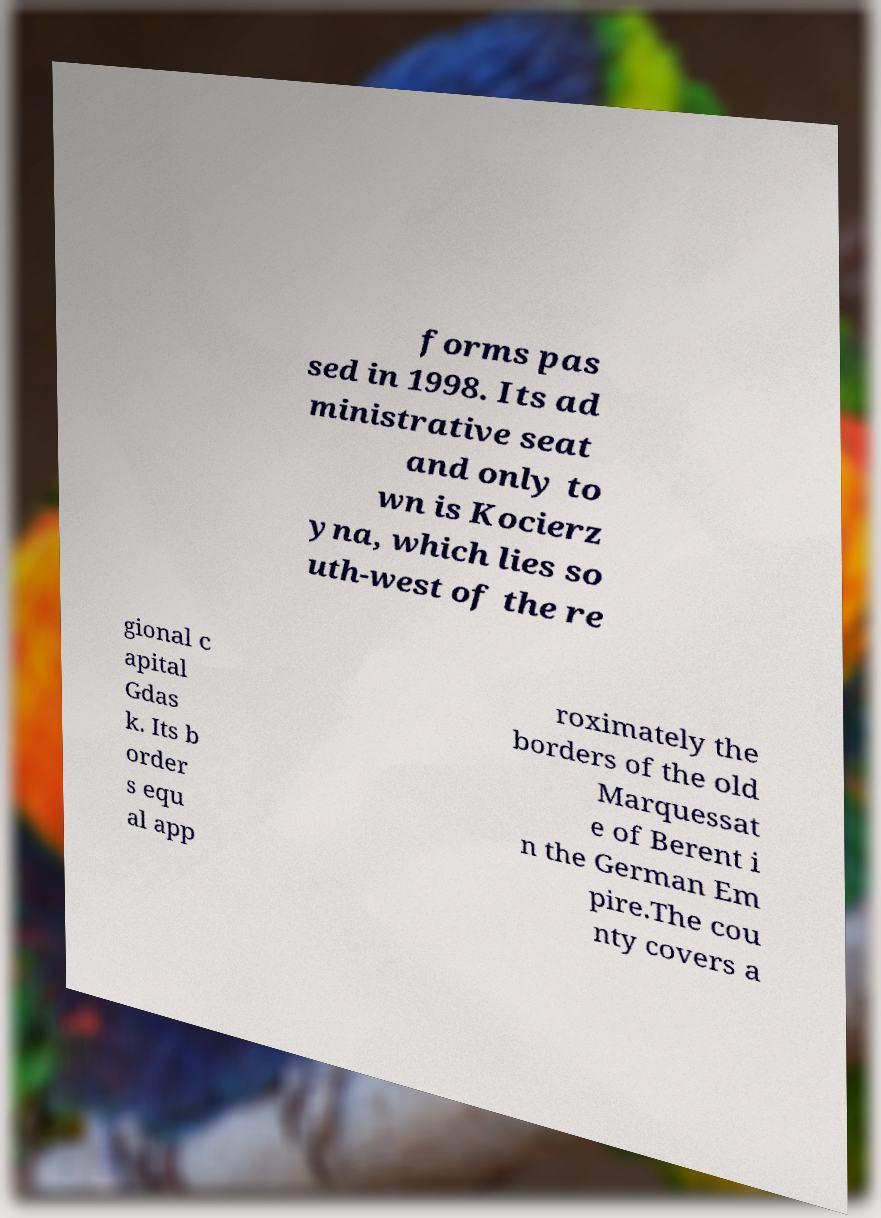Please identify and transcribe the text found in this image. forms pas sed in 1998. Its ad ministrative seat and only to wn is Kocierz yna, which lies so uth-west of the re gional c apital Gdas k. Its b order s equ al app roximately the borders of the old Marquessat e of Berent i n the German Em pire.The cou nty covers a 